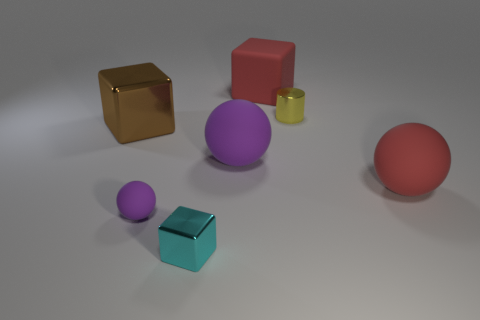How big is the red thing in front of the shiny cube behind the small purple ball?
Your answer should be very brief. Large. Is the number of big blocks in front of the small purple thing greater than the number of large blue metallic cylinders?
Ensure brevity in your answer.  No. There is a red sphere that is to the right of the red rubber block; does it have the same size as the cyan metallic block?
Give a very brief answer. No. There is a object that is in front of the brown shiny object and on the left side of the tiny shiny cube; what is its color?
Provide a succinct answer. Purple. There is a purple rubber thing that is the same size as the brown metal object; what is its shape?
Provide a succinct answer. Sphere. Is there another small matte sphere that has the same color as the small rubber ball?
Provide a succinct answer. No. Are there the same number of tiny yellow cylinders that are right of the large purple ball and big brown objects?
Provide a succinct answer. Yes. Does the small cube have the same color as the tiny metallic cylinder?
Make the answer very short. No. There is a object that is in front of the big red ball and behind the small shiny block; what size is it?
Ensure brevity in your answer.  Small. What color is the cylinder that is made of the same material as the big brown object?
Make the answer very short. Yellow. 